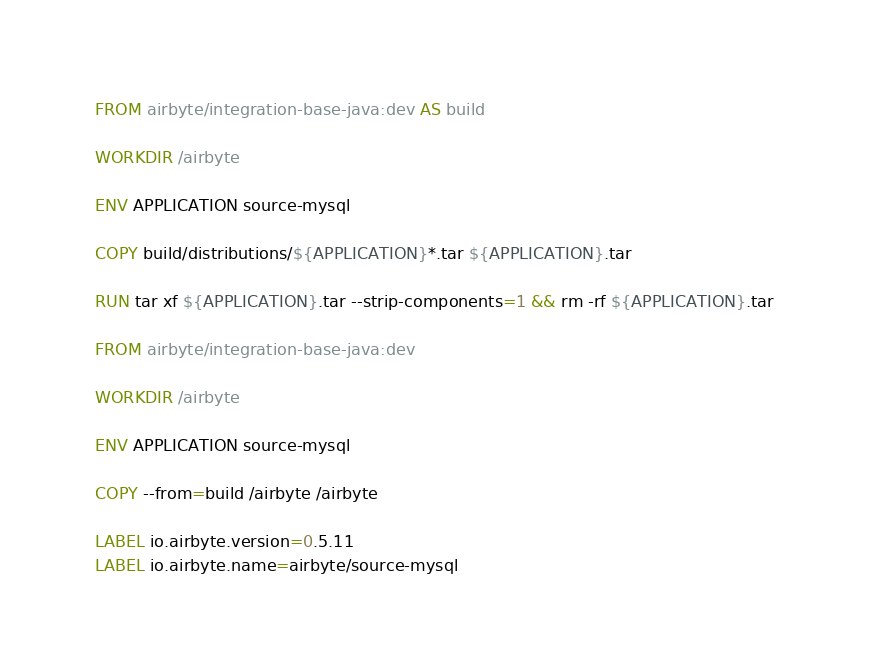Convert code to text. <code><loc_0><loc_0><loc_500><loc_500><_Dockerfile_>FROM airbyte/integration-base-java:dev AS build

WORKDIR /airbyte

ENV APPLICATION source-mysql

COPY build/distributions/${APPLICATION}*.tar ${APPLICATION}.tar

RUN tar xf ${APPLICATION}.tar --strip-components=1 && rm -rf ${APPLICATION}.tar

FROM airbyte/integration-base-java:dev

WORKDIR /airbyte

ENV APPLICATION source-mysql

COPY --from=build /airbyte /airbyte

LABEL io.airbyte.version=0.5.11
LABEL io.airbyte.name=airbyte/source-mysql
</code> 